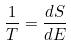Convert formula to latex. <formula><loc_0><loc_0><loc_500><loc_500>\frac { 1 } { T } = \frac { d S } { d E }</formula> 